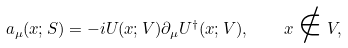<formula> <loc_0><loc_0><loc_500><loc_500>a _ { \mu } ( x ; S ) = - i U ( x ; V ) \partial _ { \mu } U ^ { \dagger } ( x ; V ) , \quad x \notin V ,</formula> 